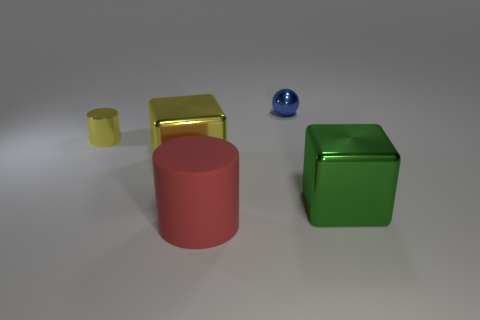Subtract all gray blocks. How many purple cylinders are left? 0 Subtract all gray spheres. Subtract all green blocks. How many objects are left? 4 Add 5 yellow objects. How many yellow objects are left? 7 Add 5 tiny green rubber spheres. How many tiny green rubber spheres exist? 5 Add 4 red matte cylinders. How many objects exist? 9 Subtract 0 gray cylinders. How many objects are left? 5 Subtract all cylinders. How many objects are left? 3 Subtract 1 blocks. How many blocks are left? 1 Subtract all brown spheres. Subtract all purple cylinders. How many spheres are left? 1 